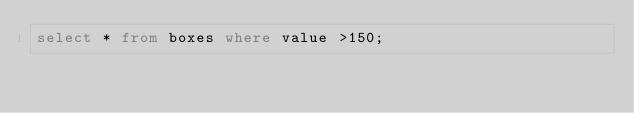<code> <loc_0><loc_0><loc_500><loc_500><_SQL_>select * from boxes where value >150;</code> 